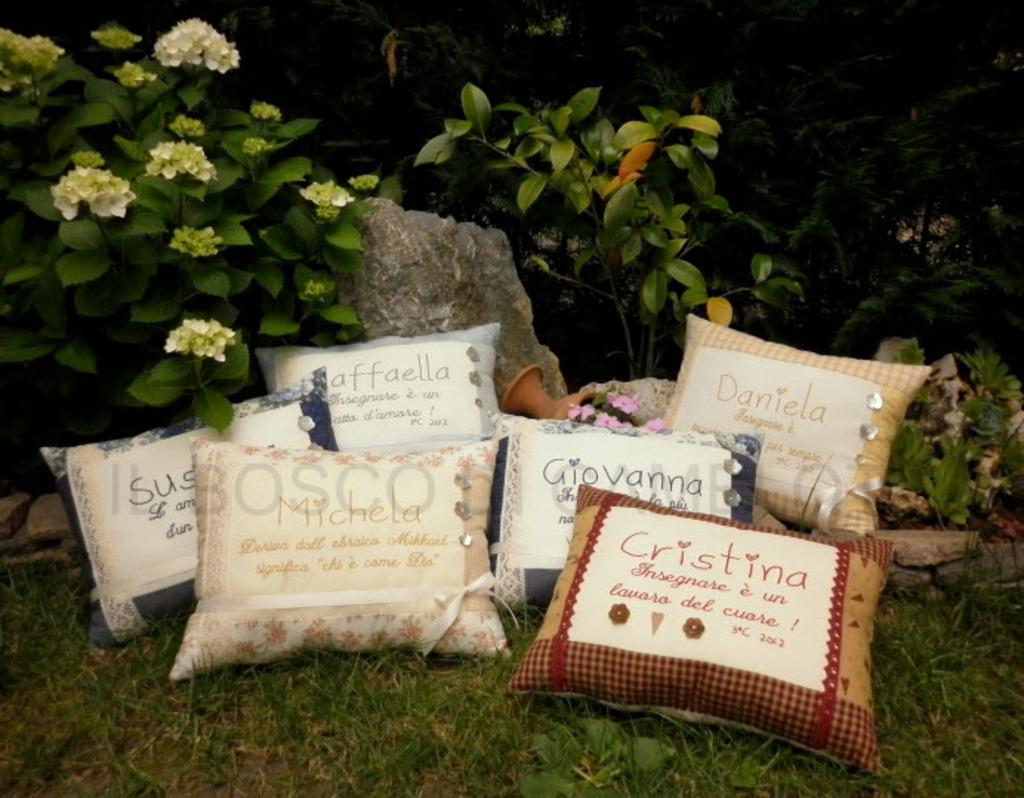Please provide a concise description of this image. In this image I can see few cushions on the grass ground and on these cushions I can see something is written. In the background I can see few flowers, few plants and number of stones. In the centre of the image I can see a spot like thing. 